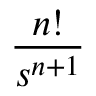<formula> <loc_0><loc_0><loc_500><loc_500>\frac { n ! } { s ^ { n + 1 } }</formula> 